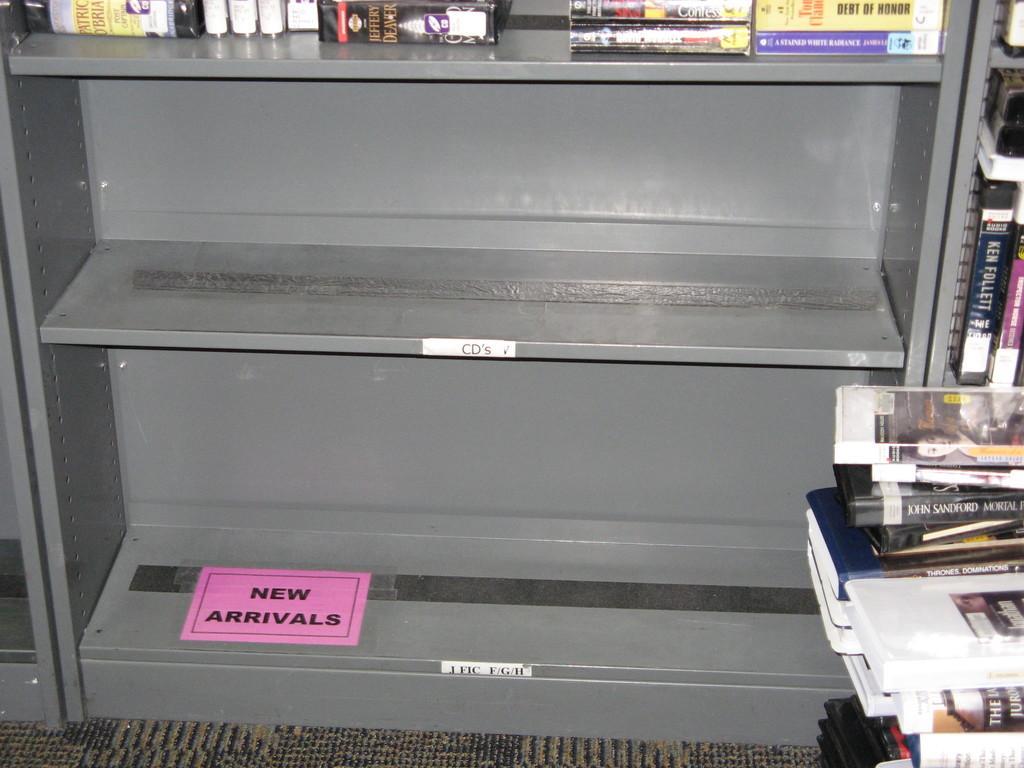In one or two sentences, can you explain what this image depicts? In this image there are few racks having books in it. Right side few books are kept one upon the other on the floor having carpet. 